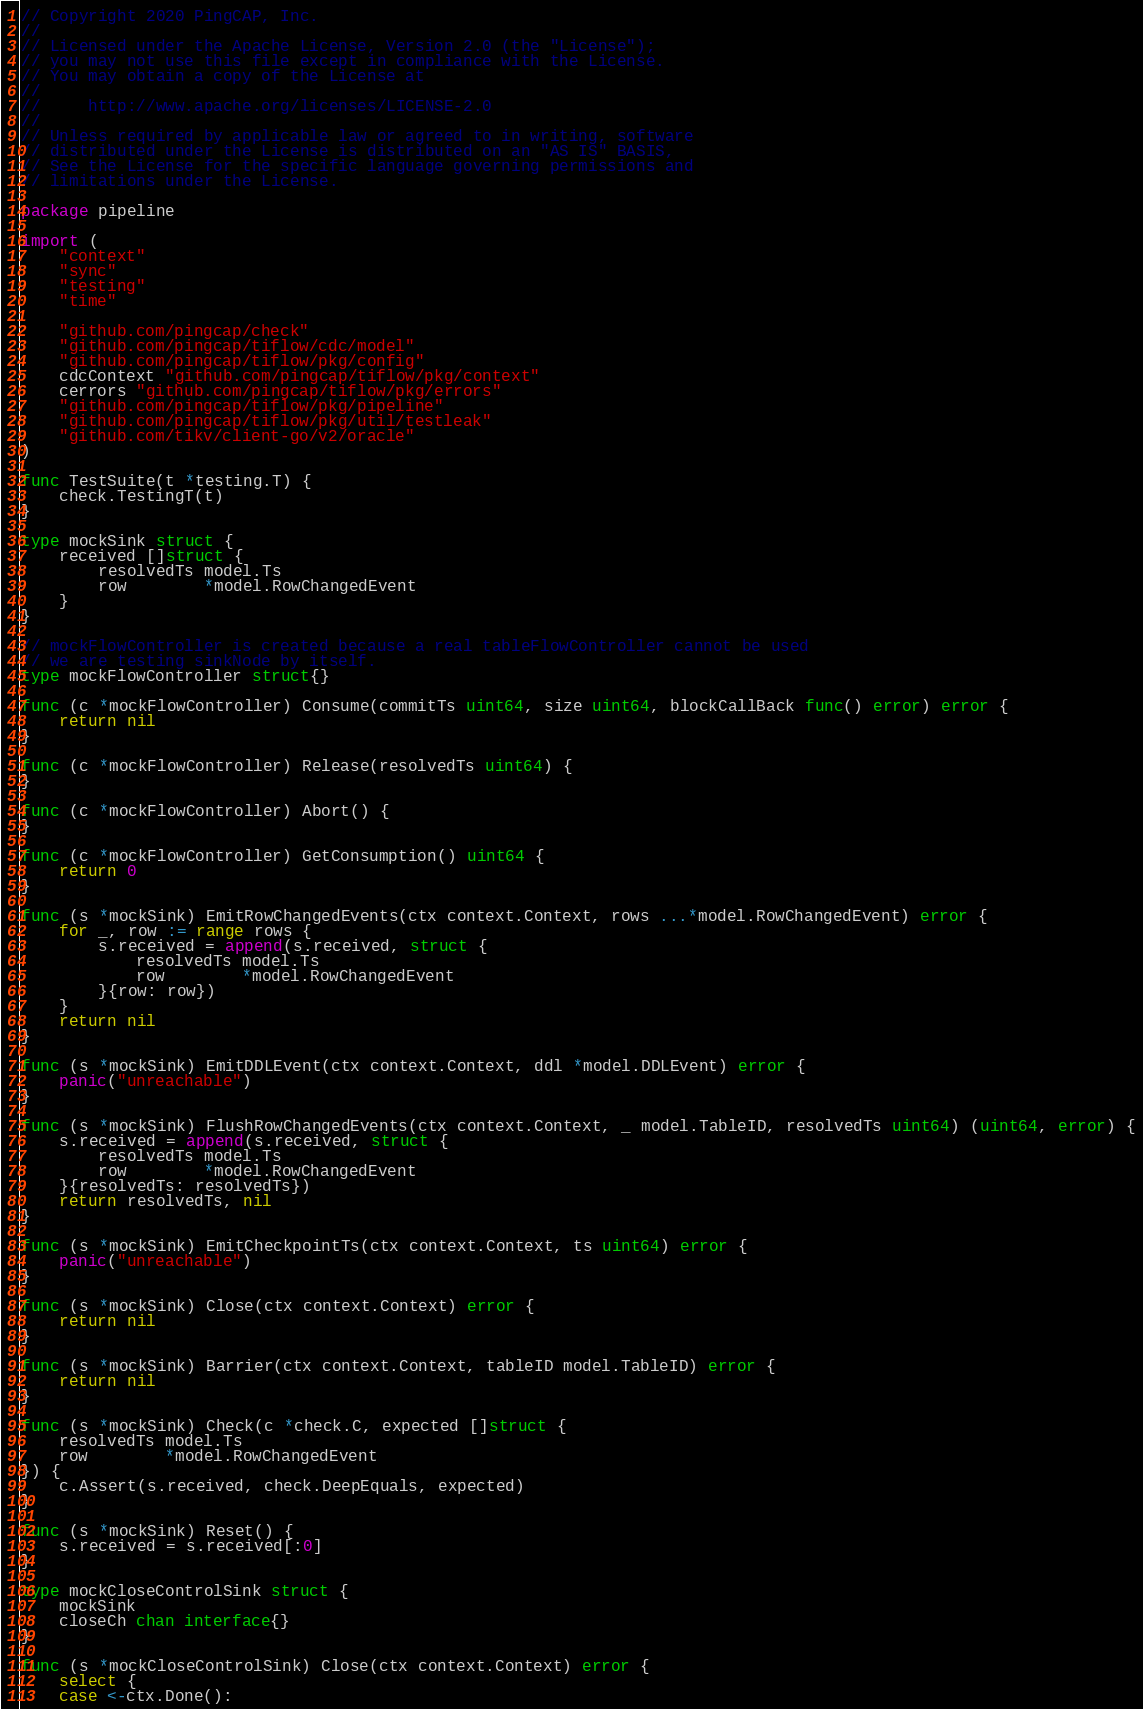<code> <loc_0><loc_0><loc_500><loc_500><_Go_>// Copyright 2020 PingCAP, Inc.
//
// Licensed under the Apache License, Version 2.0 (the "License");
// you may not use this file except in compliance with the License.
// You may obtain a copy of the License at
//
//     http://www.apache.org/licenses/LICENSE-2.0
//
// Unless required by applicable law or agreed to in writing, software
// distributed under the License is distributed on an "AS IS" BASIS,
// See the License for the specific language governing permissions and
// limitations under the License.

package pipeline

import (
	"context"
	"sync"
	"testing"
	"time"

	"github.com/pingcap/check"
	"github.com/pingcap/tiflow/cdc/model"
	"github.com/pingcap/tiflow/pkg/config"
	cdcContext "github.com/pingcap/tiflow/pkg/context"
	cerrors "github.com/pingcap/tiflow/pkg/errors"
	"github.com/pingcap/tiflow/pkg/pipeline"
	"github.com/pingcap/tiflow/pkg/util/testleak"
	"github.com/tikv/client-go/v2/oracle"
)

func TestSuite(t *testing.T) {
	check.TestingT(t)
}

type mockSink struct {
	received []struct {
		resolvedTs model.Ts
		row        *model.RowChangedEvent
	}
}

// mockFlowController is created because a real tableFlowController cannot be used
// we are testing sinkNode by itself.
type mockFlowController struct{}

func (c *mockFlowController) Consume(commitTs uint64, size uint64, blockCallBack func() error) error {
	return nil
}

func (c *mockFlowController) Release(resolvedTs uint64) {
}

func (c *mockFlowController) Abort() {
}

func (c *mockFlowController) GetConsumption() uint64 {
	return 0
}

func (s *mockSink) EmitRowChangedEvents(ctx context.Context, rows ...*model.RowChangedEvent) error {
	for _, row := range rows {
		s.received = append(s.received, struct {
			resolvedTs model.Ts
			row        *model.RowChangedEvent
		}{row: row})
	}
	return nil
}

func (s *mockSink) EmitDDLEvent(ctx context.Context, ddl *model.DDLEvent) error {
	panic("unreachable")
}

func (s *mockSink) FlushRowChangedEvents(ctx context.Context, _ model.TableID, resolvedTs uint64) (uint64, error) {
	s.received = append(s.received, struct {
		resolvedTs model.Ts
		row        *model.RowChangedEvent
	}{resolvedTs: resolvedTs})
	return resolvedTs, nil
}

func (s *mockSink) EmitCheckpointTs(ctx context.Context, ts uint64) error {
	panic("unreachable")
}

func (s *mockSink) Close(ctx context.Context) error {
	return nil
}

func (s *mockSink) Barrier(ctx context.Context, tableID model.TableID) error {
	return nil
}

func (s *mockSink) Check(c *check.C, expected []struct {
	resolvedTs model.Ts
	row        *model.RowChangedEvent
}) {
	c.Assert(s.received, check.DeepEquals, expected)
}

func (s *mockSink) Reset() {
	s.received = s.received[:0]
}

type mockCloseControlSink struct {
	mockSink
	closeCh chan interface{}
}

func (s *mockCloseControlSink) Close(ctx context.Context) error {
	select {
	case <-ctx.Done():</code> 